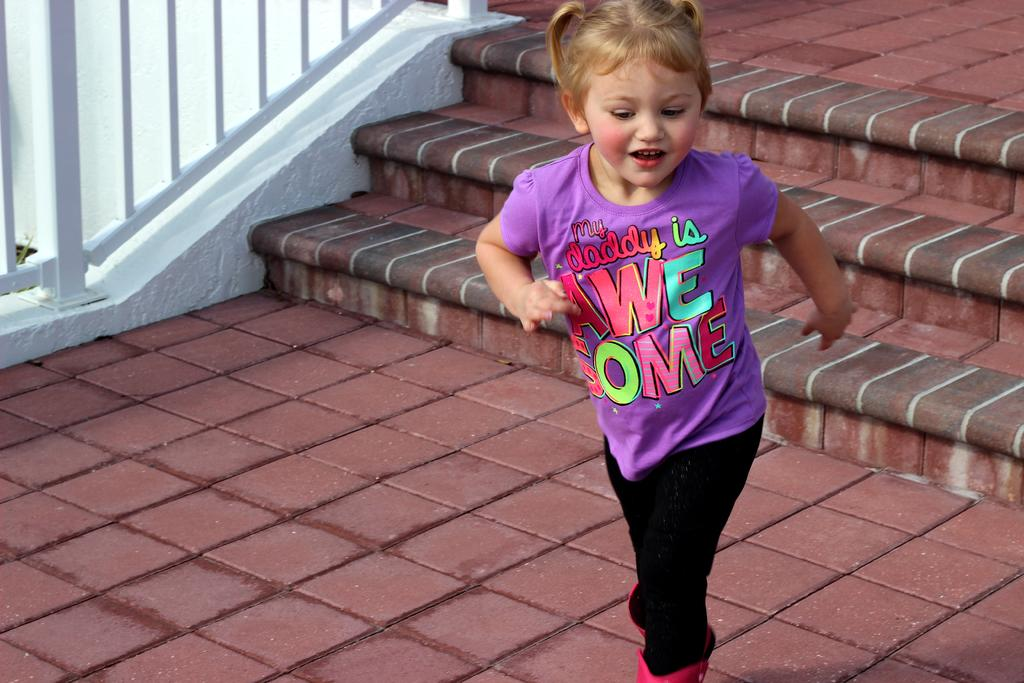Who is the main subject in the image? There is a girl in the image. What is the girl wearing? The girl is wearing a blue T-shirt. What is the girl doing in the image? The girl is running and laughing. What can be seen in the background of the image? There is a white color fence in the image, and it is near a staircase. What type of surface is the girl running on? There is grass on the surface in the image. How much debt does the girl have in the image? There is no mention of debt in the image, as it features a girl running and laughing with a fence and staircase in the background. 